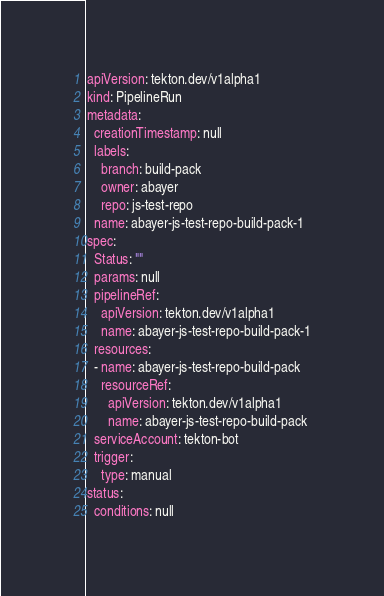<code> <loc_0><loc_0><loc_500><loc_500><_YAML_>apiVersion: tekton.dev/v1alpha1
kind: PipelineRun
metadata:
  creationTimestamp: null
  labels:
    branch: build-pack
    owner: abayer
    repo: js-test-repo
  name: abayer-js-test-repo-build-pack-1
spec:
  Status: ""
  params: null
  pipelineRef:
    apiVersion: tekton.dev/v1alpha1
    name: abayer-js-test-repo-build-pack-1
  resources:
  - name: abayer-js-test-repo-build-pack
    resourceRef:
      apiVersion: tekton.dev/v1alpha1
      name: abayer-js-test-repo-build-pack
  serviceAccount: tekton-bot
  trigger:
    type: manual
status:
  conditions: null
</code> 